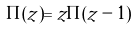Convert formula to latex. <formula><loc_0><loc_0><loc_500><loc_500>\Pi ( z ) = z \Pi ( z - 1 )</formula> 